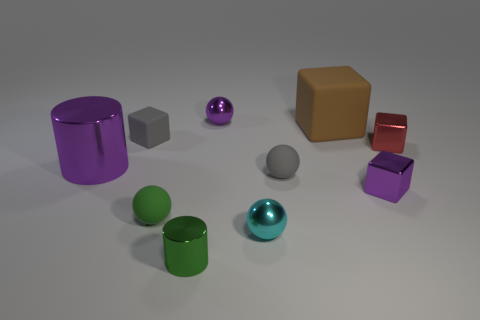What number of rubber balls have the same color as the small matte block?
Your answer should be compact. 1. What size is the purple thing that is the same shape as the small cyan thing?
Offer a very short reply. Small. The other shiny thing that is the same shape as the small cyan thing is what color?
Give a very brief answer. Purple. There is a large object that is in front of the gray matte block; is it the same color as the tiny block left of the tiny metallic cylinder?
Your answer should be compact. No. Is the number of rubber objects that are to the right of the green matte sphere greater than the number of tiny cyan metallic balls?
Your answer should be compact. Yes. What number of other things are the same size as the red metal thing?
Offer a terse response. 7. What number of matte things are in front of the red cube and on the left side of the tiny purple ball?
Offer a terse response. 1. Is the material of the green ball that is behind the small cyan shiny sphere the same as the small cylinder?
Offer a very short reply. No. What is the shape of the small purple object in front of the large object that is to the right of the small gray matte object to the left of the small green shiny cylinder?
Your answer should be very brief. Cube. Is the number of small green things that are right of the small cylinder the same as the number of large shiny cylinders behind the purple metal cube?
Provide a short and direct response. No. 